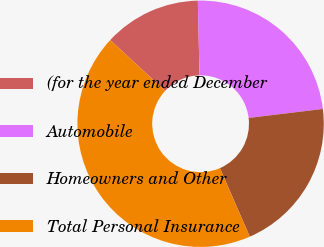Convert chart. <chart><loc_0><loc_0><loc_500><loc_500><pie_chart><fcel>(for the year ended December<fcel>Automobile<fcel>Homeowners and Other<fcel>Total Personal Insurance<nl><fcel>12.75%<fcel>23.44%<fcel>20.38%<fcel>43.43%<nl></chart> 